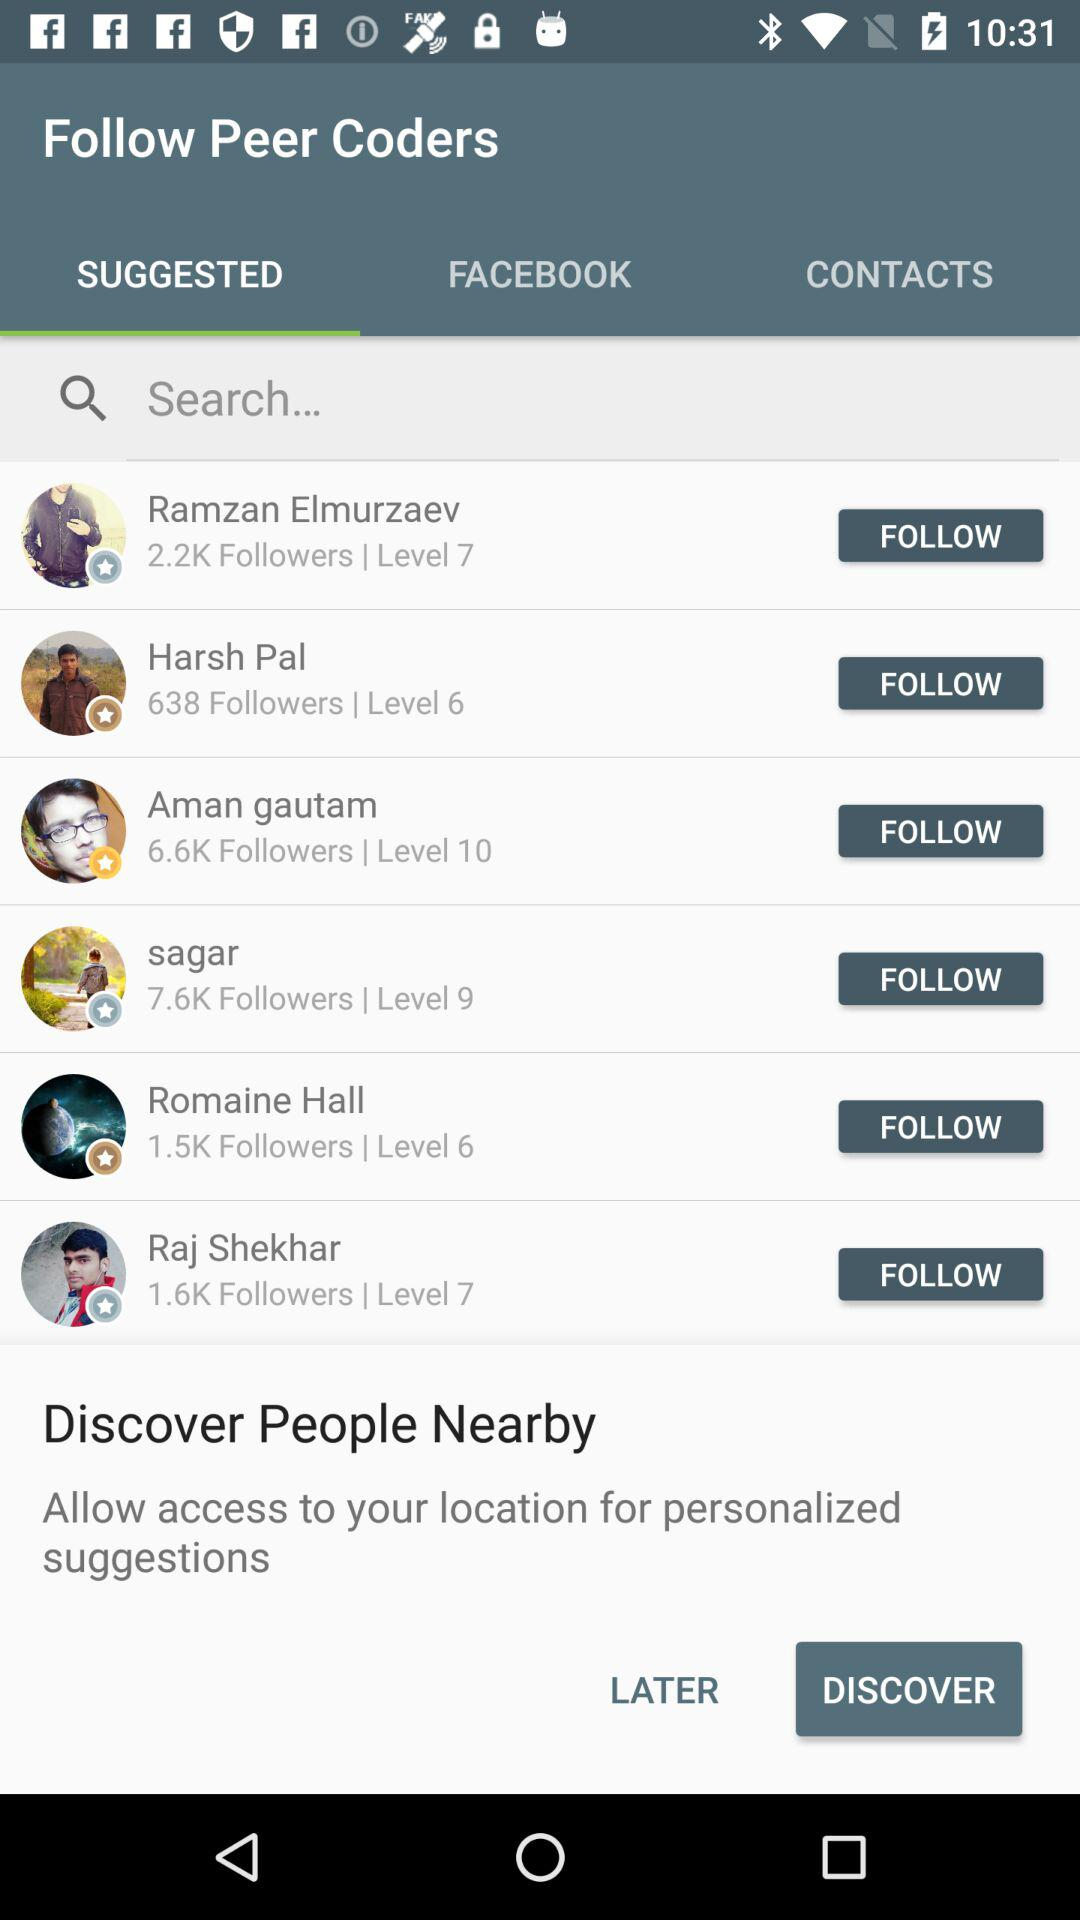What is the level number for Aman Gautam? The level number for Aman Gautam is 10. 